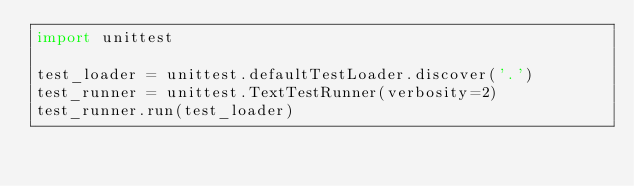Convert code to text. <code><loc_0><loc_0><loc_500><loc_500><_Python_>import unittest

test_loader = unittest.defaultTestLoader.discover('.')
test_runner = unittest.TextTestRunner(verbosity=2)
test_runner.run(test_loader)
</code> 